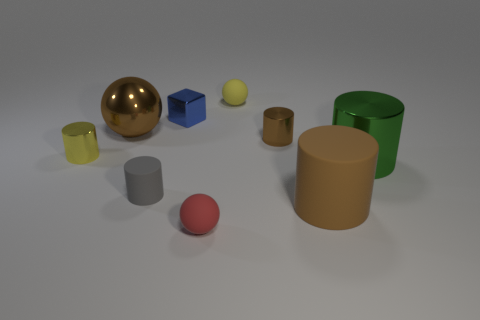Does the metallic cylinder that is to the left of the tiny yellow rubber object have the same color as the matte sphere that is behind the big brown rubber object?
Offer a terse response. Yes. Is the big brown object on the left side of the red thing made of the same material as the large green thing?
Ensure brevity in your answer.  Yes. Is there a tiny matte ball behind the tiny matte ball in front of the tiny yellow cylinder?
Provide a succinct answer. Yes. What material is the other tiny thing that is the same shape as the small yellow matte object?
Your answer should be very brief. Rubber. Is the number of large brown cylinders that are right of the blue metal object greater than the number of green cylinders behind the brown metal ball?
Your response must be concise. Yes. What is the shape of the brown object that is the same material as the small yellow ball?
Keep it short and to the point. Cylinder. Is the number of rubber objects that are behind the large green cylinder greater than the number of gray balls?
Your response must be concise. Yes. What number of big spheres have the same color as the large rubber cylinder?
Offer a terse response. 1. What number of other objects are there of the same color as the large rubber object?
Your response must be concise. 2. Are there more green cylinders than big red rubber cubes?
Keep it short and to the point. Yes. 